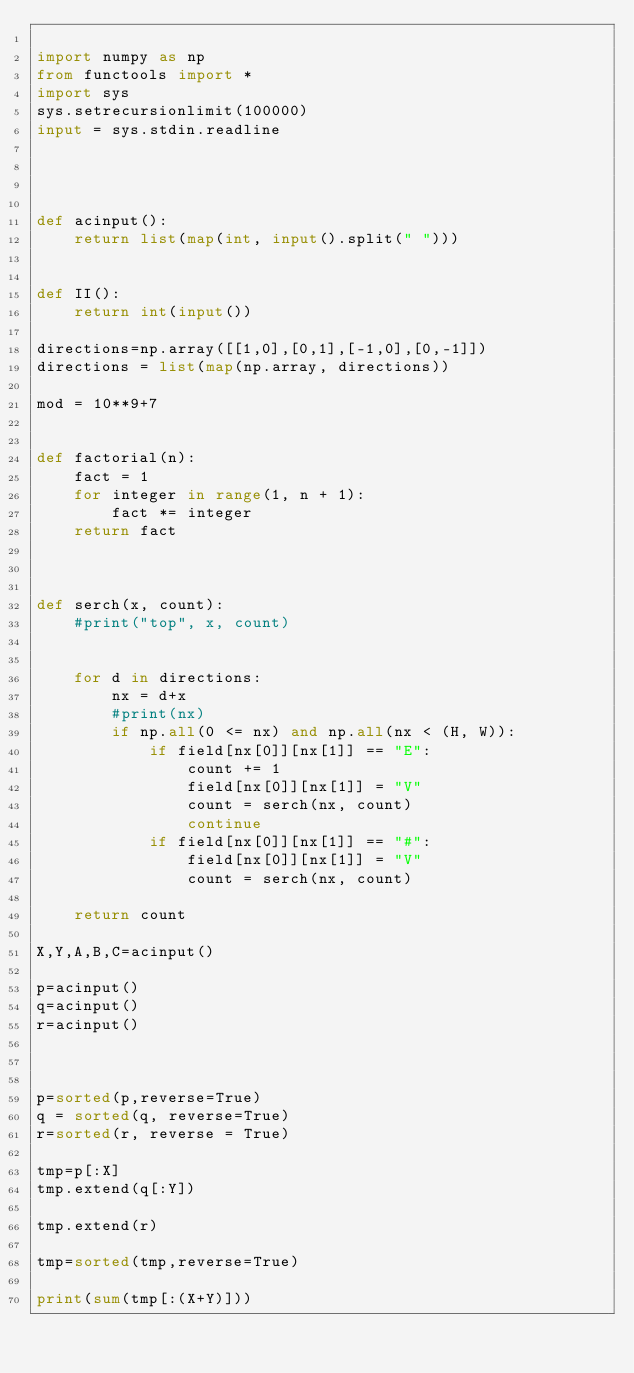Convert code to text. <code><loc_0><loc_0><loc_500><loc_500><_Python_>
import numpy as np
from functools import *
import sys
sys.setrecursionlimit(100000)
input = sys.stdin.readline




def acinput():
    return list(map(int, input().split(" ")))


def II():
    return int(input())

directions=np.array([[1,0],[0,1],[-1,0],[0,-1]])
directions = list(map(np.array, directions))

mod = 10**9+7


def factorial(n):
    fact = 1
    for integer in range(1, n + 1):
        fact *= integer
    return fact



def serch(x, count):
    #print("top", x, count)
            

    for d in directions:
        nx = d+x
        #print(nx)
        if np.all(0 <= nx) and np.all(nx < (H, W)):
            if field[nx[0]][nx[1]] == "E":
                count += 1 
                field[nx[0]][nx[1]] = "V"
                count = serch(nx, count)  
                continue
            if field[nx[0]][nx[1]] == "#":
                field[nx[0]][nx[1]] = "V"
                count = serch(nx, count)    
                 
    return count

X,Y,A,B,C=acinput()

p=acinput()
q=acinput()
r=acinput()



p=sorted(p,reverse=True)
q = sorted(q, reverse=True)
r=sorted(r, reverse = True)

tmp=p[:X]
tmp.extend(q[:Y])

tmp.extend(r)

tmp=sorted(tmp,reverse=True)

print(sum(tmp[:(X+Y)]))</code> 